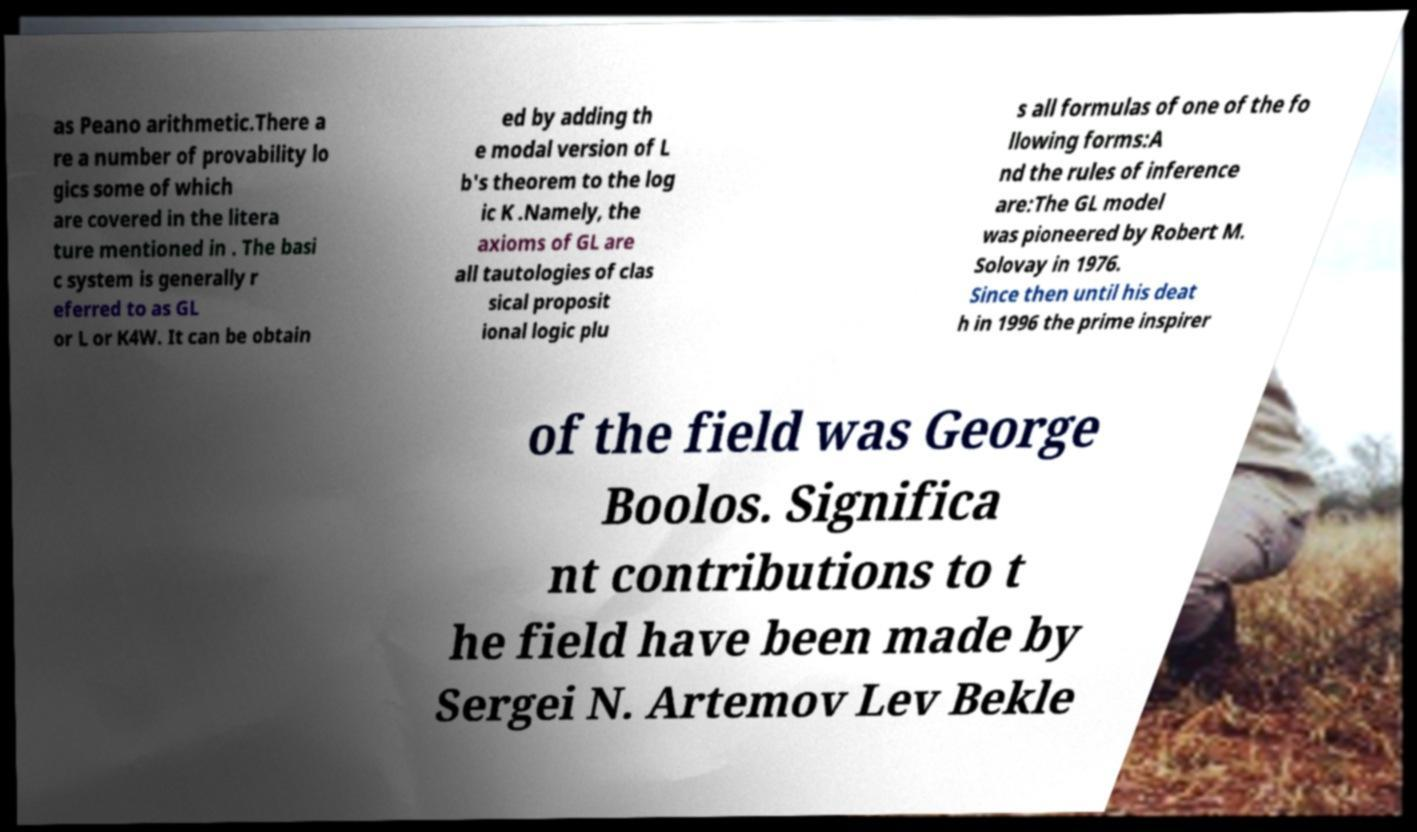What messages or text are displayed in this image? I need them in a readable, typed format. as Peano arithmetic.There a re a number of provability lo gics some of which are covered in the litera ture mentioned in . The basi c system is generally r eferred to as GL or L or K4W. It can be obtain ed by adding th e modal version of L b's theorem to the log ic K .Namely, the axioms of GL are all tautologies of clas sical proposit ional logic plu s all formulas of one of the fo llowing forms:A nd the rules of inference are:The GL model was pioneered by Robert M. Solovay in 1976. Since then until his deat h in 1996 the prime inspirer of the field was George Boolos. Significa nt contributions to t he field have been made by Sergei N. Artemov Lev Bekle 